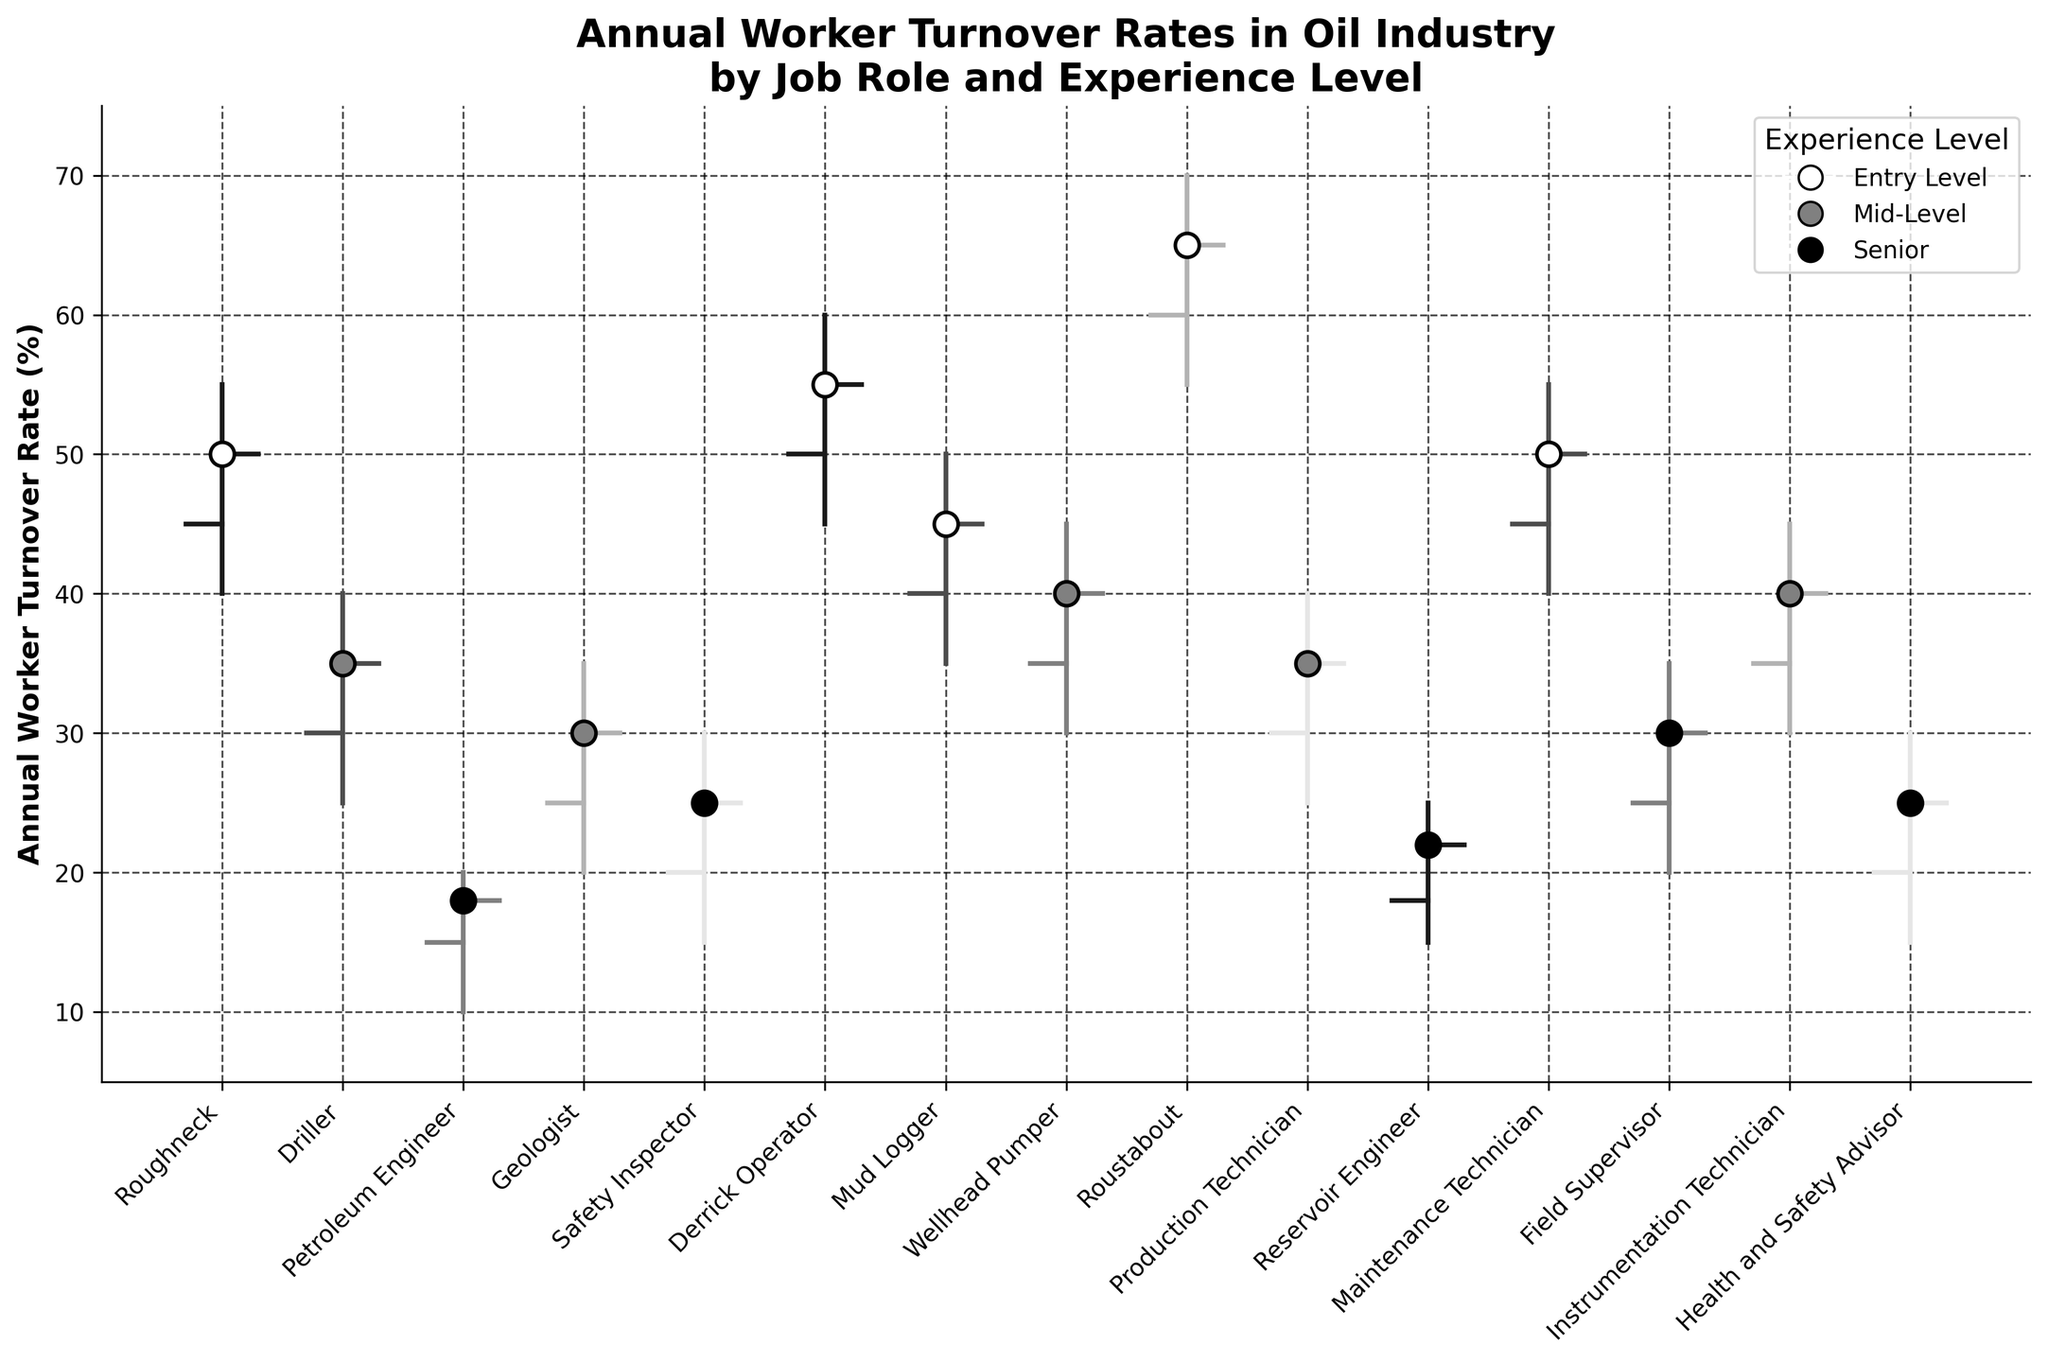What's the title of the chart? The title of the chart is displayed at the top of the figure. It reads "Annual Worker Turnover Rates in Oil Industry by Job Role and Experience Level".
Answer: Annual Worker Turnover Rates in Oil Industry by Job Role and Experience Level What is the turnover rate for Roughnecks at the opening and closing of the year? The turnover rates for Roughnecks at the opening and closing are represented by the "open" and "close" values on the OHLC chart. For Roughnecks, the open rate is 45% and the close rate is 50%.
Answer: Opening: 45%, Closing: 50% Which job role has the highest turnover rate at any point during the year? The highest turnover rate is indicated by the "high" value in the OHLC chart. The Roustabout job role has the highest turnover rate at any point during the year, which is 70%.
Answer: Roustabout Compare the closing turnover rates for Entry Level employees in any two roles. First, identify all Entry Level roles and their closing rates: Roughneck (50%), Derrick Operator (55%), Mud Logger (45%), Roustabout (65%), and Maintenance Technician (50%). Then select any two roles and compare their closing rates, for example Roughneck (50%) and Roustabout (65%).
Answer: Roughneck: 50%, Roustabout: 65% What is the average closing turnover rate across all job roles? To find the average closing turnover rate, sum all the closing rates and divide by the number of job roles. The sum of closing rates is 50 + 35 + 18 + 30 + 25 + 55 + 45 + 40 + 65 + 35 + 22 + 50 + 30 + 40 + 25 = 565. There are 15 job roles. The average is 565 / 15 = 37.67%.
Answer: 37.67% For which job roles is the low turnover rate lower than 20%? The low turnover rate for each role is indicated by the "low" value. Job roles with low rates < 20% are Petroleum Engineer (10%), Safety Inspector (15%), Reservoir Engineer (15%), and Health and Safety Advisor (15%).
Answer: Petroleum Engineer, Safety Inspector, Reservoir Engineer, Health and Safety Advisor Which job role has the smallest range between its highest and lowest turnover rates? The range is found by subtracting the low value from the high value. Compute for each role and compare: Roughneck (55-40=15), Driller (40-25=15), Petroleum Engineer (20-10=10), Geologist (35-20=15), Safety Inspector (30-15=15), Derrick Operator (60-45=15), Mud Logger (50-35=15), Wellhead Pumper (45-30=15), Roustabout (70-55=15), Production Technician (40-25=15), Reservoir Engineer (25-15=10), Maintenance Technician (55-40=15), Field Supervisor (35-20=15), Instrumentation Technician (45-30=15), Health and Safety Advisor (30-15=15). The smallest range is 10, for Petroleum Engineer and Reservoir Engineer.
Answer: Petroleum Engineer, Reservoir Engineer 